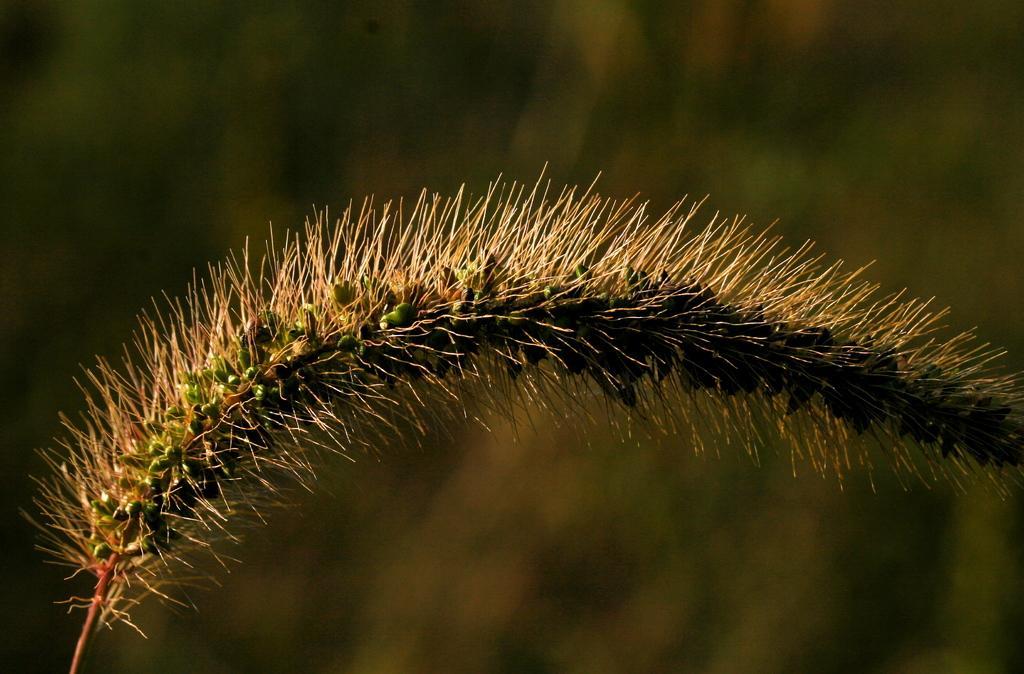Can you describe this image briefly? In this picture there is a type of the plant. Behind there is a blur background. 